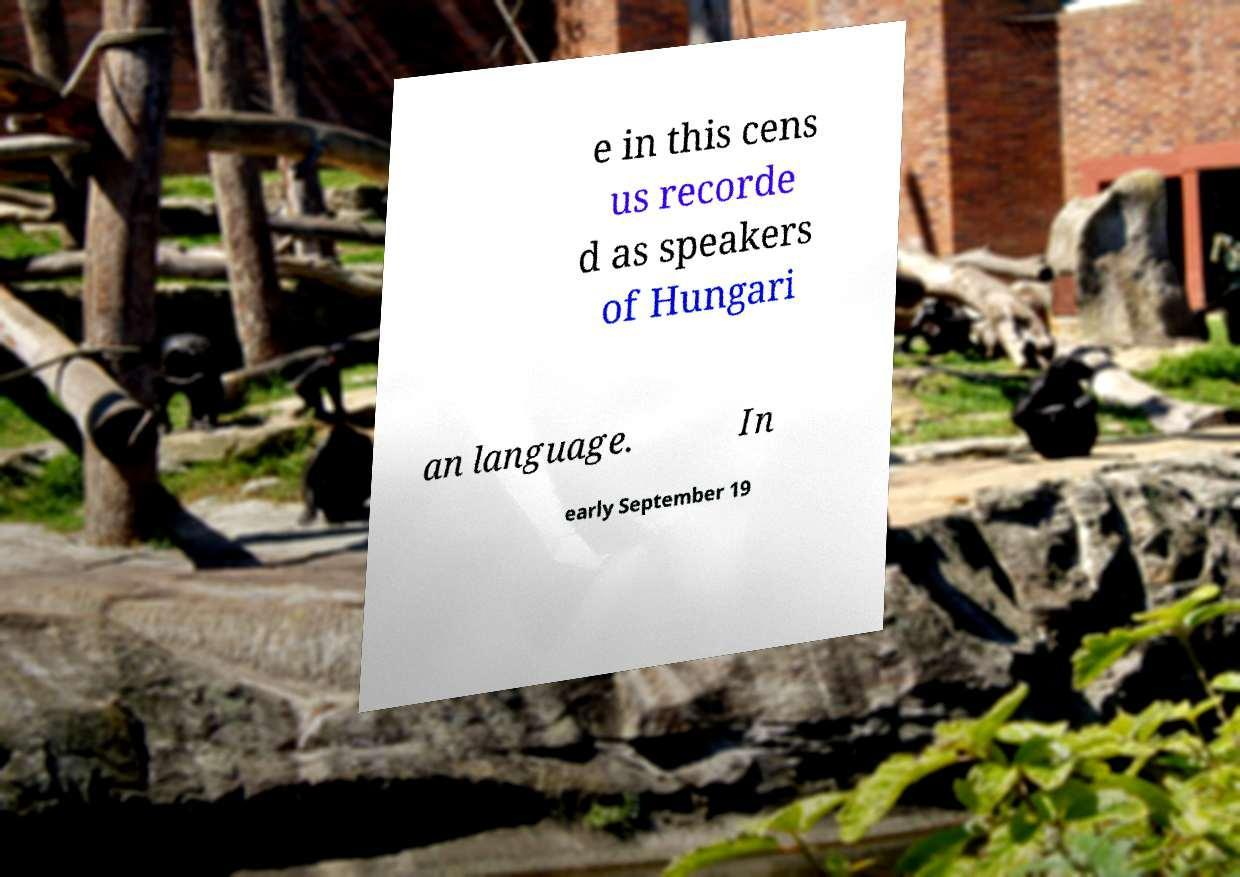Can you read and provide the text displayed in the image?This photo seems to have some interesting text. Can you extract and type it out for me? e in this cens us recorde d as speakers of Hungari an language. In early September 19 